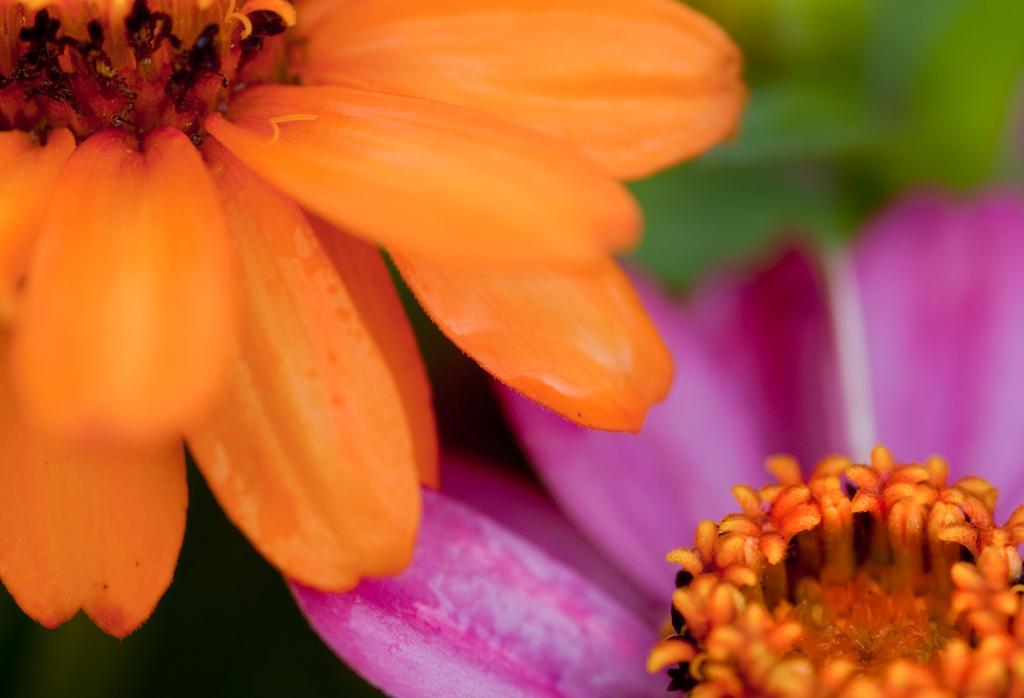Can you describe this image briefly? In this picture we observe two beautiful flowers one is orange and the other is pink. 